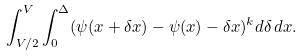<formula> <loc_0><loc_0><loc_500><loc_500>\int _ { V / 2 } ^ { V } \int _ { 0 } ^ { \Delta } ( \psi ( x + \delta x ) - \psi ( x ) - \delta x ) ^ { k } d \delta \, d x .</formula> 